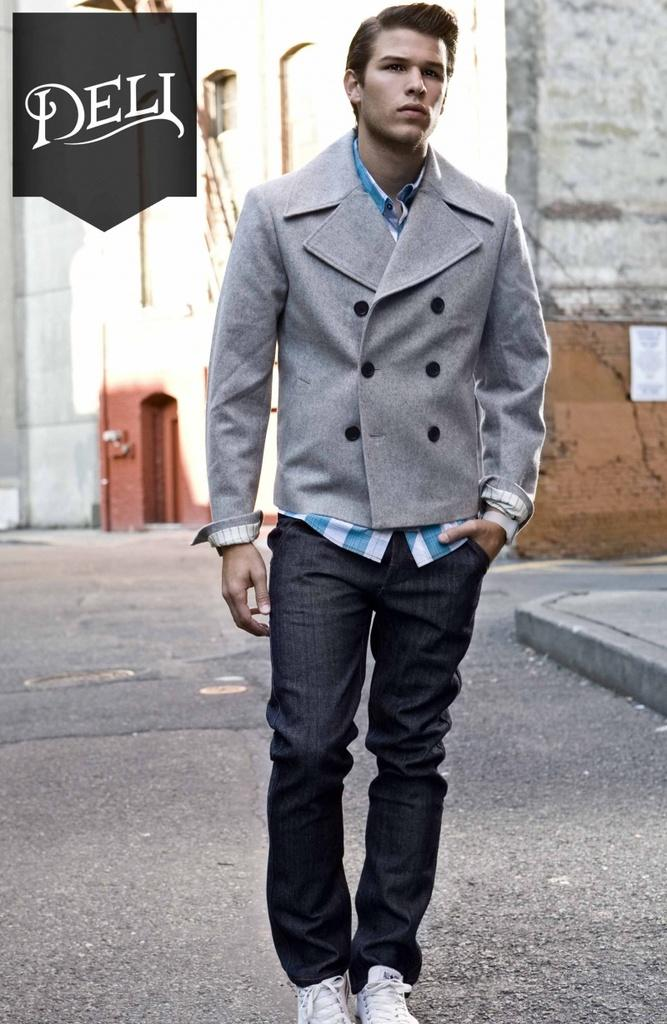What is the main subject of the image? There is a person standing in the image. Can you describe the person's clothing? The person is wearing a dress and pants. What colors can be seen on the dress? The dress has colors of ash, blue, and white. What can be seen in the background of the image? There is a building visible in the background of the image. Can you tell me how many toads are sitting on the person's shoulder in the image? There are no toads present in the image; the person is standing alone. What type of art is displayed on the building in the background? There is no art displayed on the building in the background; only the building itself is visible. 